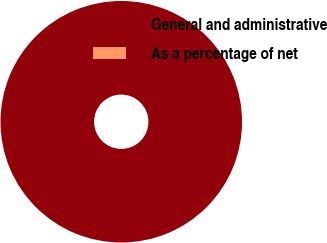Convert chart to OTSL. <chart><loc_0><loc_0><loc_500><loc_500><pie_chart><fcel>General and administrative<fcel>As a percentage of net<nl><fcel>100.0%<fcel>0.0%<nl></chart> 